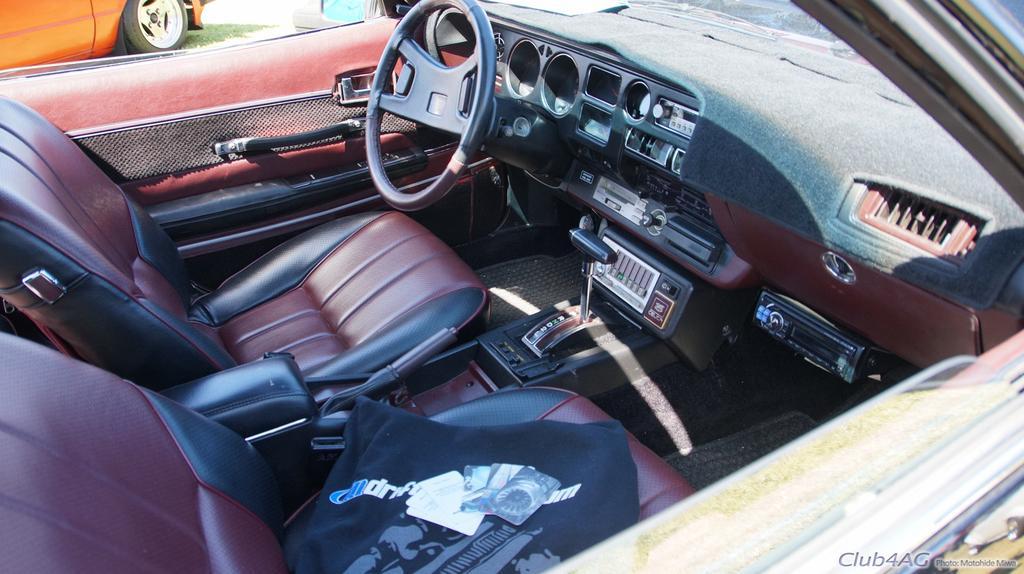In one or two sentences, can you explain what this image depicts? This is a zoomed in picture of the car. On the left we can see the seats and there is a black color object placed on the seat. On the right there is a steering wheel, door, windshield and some other parts of the car. I n the background there is an orange color car seems to be parked on the ground and we can see the small amount of green grass. 